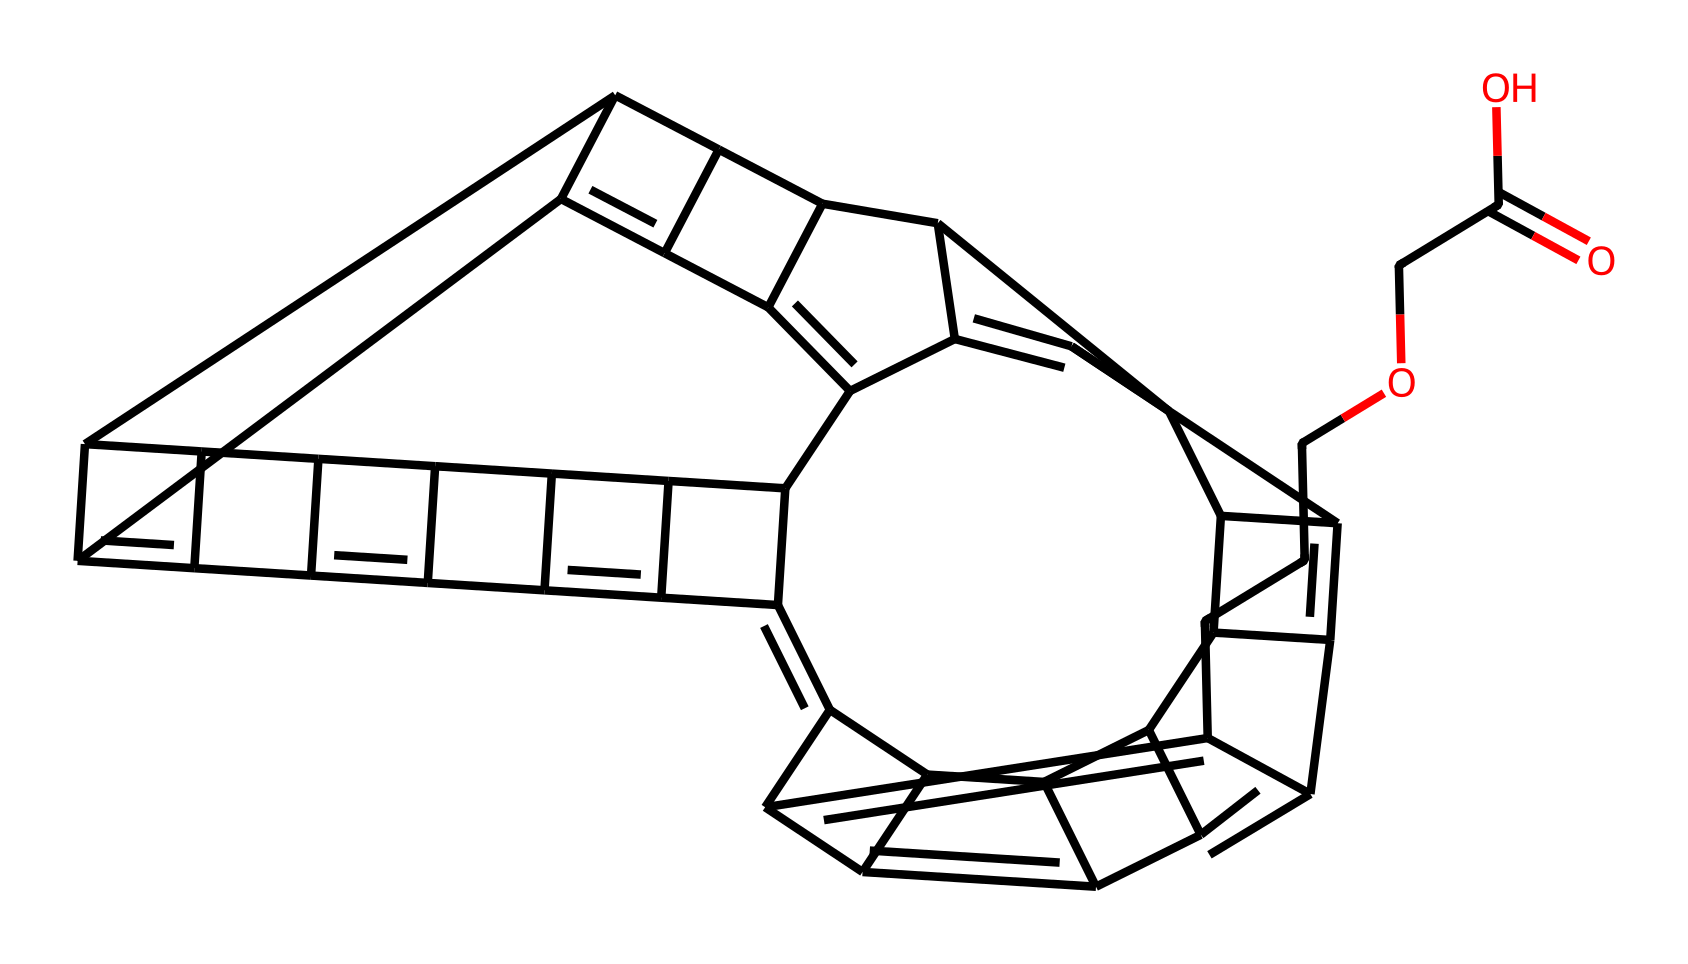What is the molecular formula of this fullerene derivative? To determine the molecular formula, we analyze the structure encoded in the SMILES representation, counting the carbon (C) and oxygen (O) atoms. The carbon atoms in the structure total to 60, and there are 2 oxygen atoms. Therefore, the molecular formula is C60H90O2 considering typical valence rules for fullerene derivatives while filling hydrogen around carbon.
Answer: C60H90O2 How many rings are present in the fullerene structure? By examining the SMILES structure, we can see that the numbering indicates connections between various carbon atoms. The structure loops back at certain points, indicating networks of several interconnected rings. Counting these connections leads us to identify a total of 12 rings in this fullerene-derived compound.
Answer: 12 What functional group is indicated in the structure? The presence of the segment "C(=O)O" in the SMILES suggests a carboxylic acid functional group due to the carbon atom connected to both a carbonyl (C=O) and a hydroxyl (O-H) group. This group is crucial for the water purification characteristics of the compound.
Answer: carboxylic acid How can this compound potentially purify water? The carboxylic acid functional group enhances the compound's ability to form hydrogen bonds and interact with water molecules. Thus, the fullerene structure's specific arrangement could allow for the adsorption of contaminants, facilitating their removal from water. The unique properties of fullerenes may also contribute to the capture of heavy metals or organic pollutants.
Answer: adsorption What type of bonding predominates in fullerenes? Fullerenes exhibit a significant amount of covalent bonding due to the carbon-carbon bonds formed between the carbon atoms within the structure. These bonds enable the stability and rigidity of the fullerene's spherical or tubular shape while aiding in effective interaction with other substances.
Answer: covalent bonding 